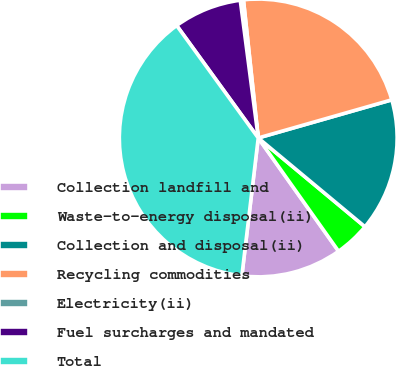Convert chart to OTSL. <chart><loc_0><loc_0><loc_500><loc_500><pie_chart><fcel>Collection landfill and<fcel>Waste-to-energy disposal(ii)<fcel>Collection and disposal(ii)<fcel>Recycling commodities<fcel>Electricity(ii)<fcel>Fuel surcharges and mandated<fcel>Total<nl><fcel>11.7%<fcel>4.14%<fcel>15.47%<fcel>22.27%<fcel>0.37%<fcel>7.92%<fcel>38.13%<nl></chart> 